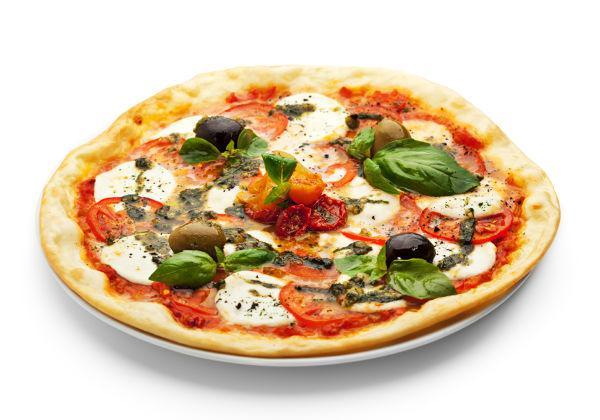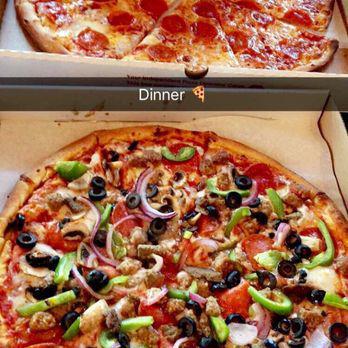The first image is the image on the left, the second image is the image on the right. Examine the images to the left and right. Is the description "There are two pizzas in the right image." accurate? Answer yes or no. Yes. The first image is the image on the left, the second image is the image on the right. Assess this claim about the two images: "All pizzas are round pizzas.". Correct or not? Answer yes or no. Yes. 